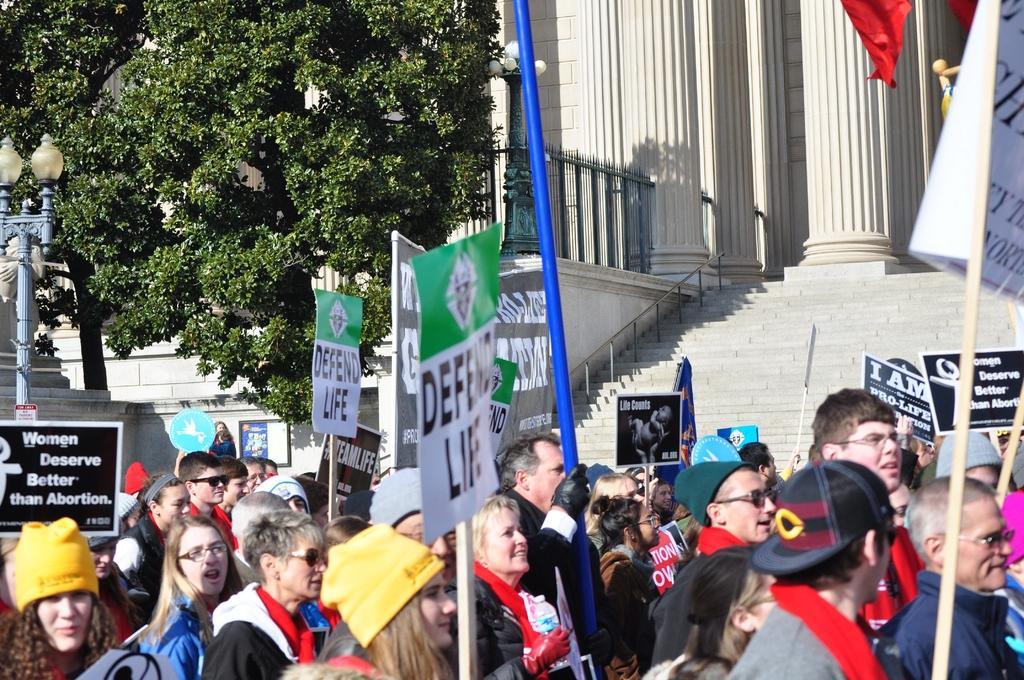How would you summarize this image in a sentence or two? In this image we can see people are protesting, they are holding banners in their hand. Behind one building and stairs are present. To the left side of the image one tree and light pole is available. 